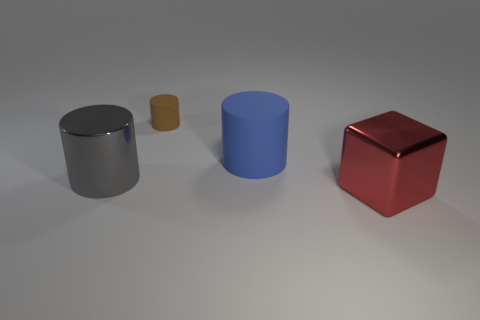Subtract all large cylinders. How many cylinders are left? 1 Add 4 green metallic objects. How many objects exist? 8 Subtract all cubes. How many objects are left? 3 Subtract 1 cylinders. How many cylinders are left? 2 Subtract all blue cylinders. How many cylinders are left? 2 Subtract all red balls. How many brown cylinders are left? 1 Subtract all large red shiny things. Subtract all large matte cylinders. How many objects are left? 2 Add 4 gray things. How many gray things are left? 5 Add 4 tiny shiny cylinders. How many tiny shiny cylinders exist? 4 Subtract 1 blue cylinders. How many objects are left? 3 